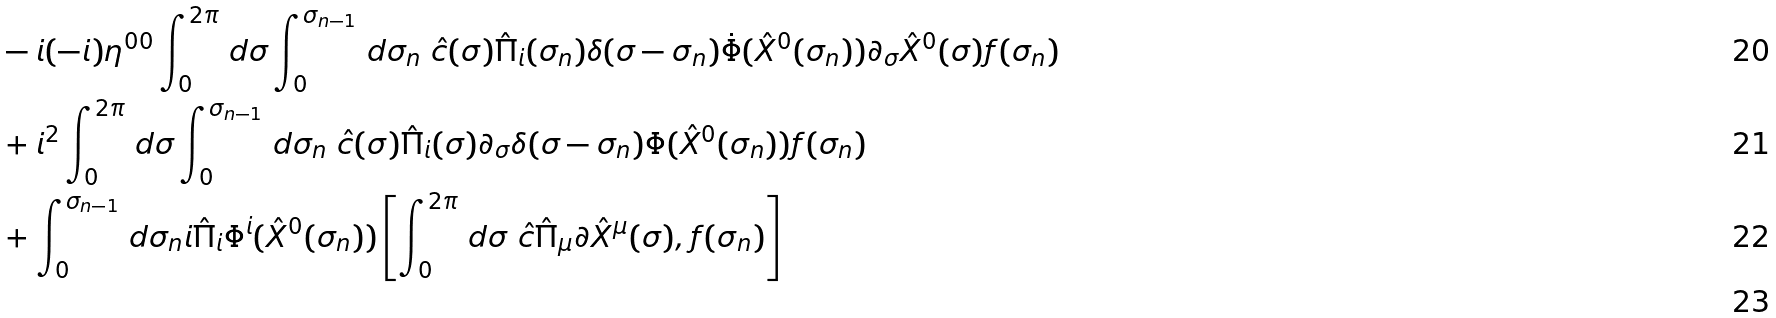Convert formula to latex. <formula><loc_0><loc_0><loc_500><loc_500>& - i ( - i ) \eta ^ { 0 0 } \int _ { 0 } ^ { 2 \pi } \, d \sigma \int _ { 0 } ^ { \sigma _ { n - 1 } } \, d \sigma _ { n } \ \hat { c } ( \sigma ) \hat { \Pi } _ { i } ( \sigma _ { n } ) \delta ( \sigma - \sigma _ { n } ) \dot { \Phi } ( \hat { X } ^ { 0 } ( \sigma _ { n } ) ) \partial _ { \sigma } \hat { X } ^ { 0 } ( \sigma ) f ( \sigma _ { n } ) \\ & + i ^ { 2 } \int _ { 0 } ^ { 2 \pi } \, d \sigma \int _ { 0 } ^ { \sigma _ { n - 1 } } \, d \sigma _ { n } \ \hat { c } ( \sigma ) \hat { \Pi } _ { i } ( \sigma ) \partial _ { \sigma } \delta ( \sigma - \sigma _ { n } ) \Phi ( \hat { X } ^ { 0 } ( \sigma _ { n } ) ) f ( \sigma _ { n } ) \\ & + \int _ { 0 } ^ { \sigma _ { n - 1 } } \, d \sigma _ { n } i \hat { \Pi } _ { i } \Phi ^ { i } ( \hat { X } ^ { 0 } ( \sigma _ { n } ) ) \left [ \int _ { 0 } ^ { 2 \pi } \, d \sigma \ \hat { c } \hat { \Pi } _ { \mu } \partial \hat { X } ^ { \mu } ( \sigma ) , f ( \sigma _ { n } ) \right ] \\</formula> 